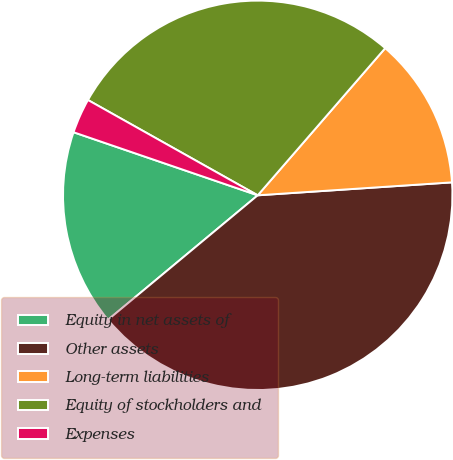Convert chart to OTSL. <chart><loc_0><loc_0><loc_500><loc_500><pie_chart><fcel>Equity in net assets of<fcel>Other assets<fcel>Long-term liabilities<fcel>Equity of stockholders and<fcel>Expenses<nl><fcel>16.29%<fcel>40.02%<fcel>12.58%<fcel>28.22%<fcel>2.89%<nl></chart> 